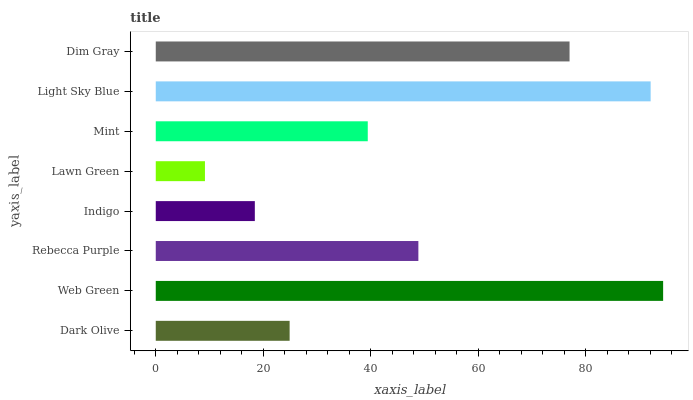Is Lawn Green the minimum?
Answer yes or no. Yes. Is Web Green the maximum?
Answer yes or no. Yes. Is Rebecca Purple the minimum?
Answer yes or no. No. Is Rebecca Purple the maximum?
Answer yes or no. No. Is Web Green greater than Rebecca Purple?
Answer yes or no. Yes. Is Rebecca Purple less than Web Green?
Answer yes or no. Yes. Is Rebecca Purple greater than Web Green?
Answer yes or no. No. Is Web Green less than Rebecca Purple?
Answer yes or no. No. Is Rebecca Purple the high median?
Answer yes or no. Yes. Is Mint the low median?
Answer yes or no. Yes. Is Light Sky Blue the high median?
Answer yes or no. No. Is Dark Olive the low median?
Answer yes or no. No. 